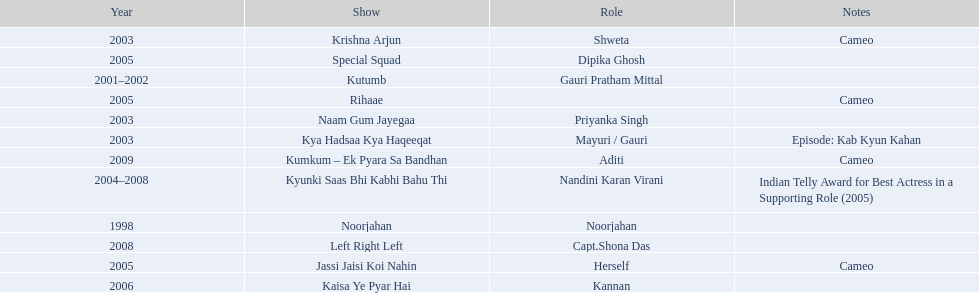In 1998 what was the role of gauri pradhan tejwani? Noorjahan. In 2003 what show did gauri have a cameo in? Krishna Arjun. Gauri was apart of which television show for the longest? Kyunki Saas Bhi Kabhi Bahu Thi. 